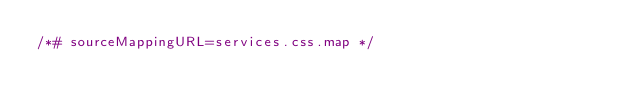<code> <loc_0><loc_0><loc_500><loc_500><_CSS_>/*# sourceMappingURL=services.css.map */
</code> 